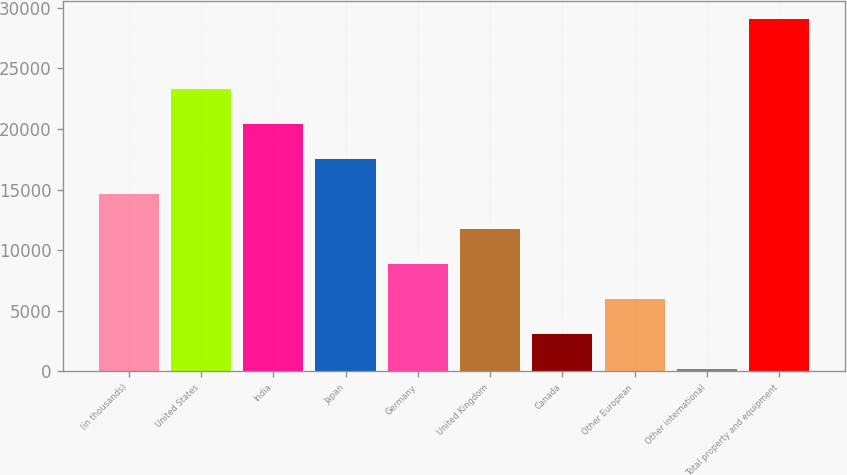<chart> <loc_0><loc_0><loc_500><loc_500><bar_chart><fcel>(in thousands)<fcel>United States<fcel>India<fcel>Japan<fcel>Germany<fcel>United Kingdom<fcel>Canada<fcel>Other European<fcel>Other international<fcel>Total property and equipment<nl><fcel>14620.5<fcel>23297.4<fcel>20405.1<fcel>17512.8<fcel>8835.9<fcel>11728.2<fcel>3051.3<fcel>5943.6<fcel>159<fcel>29082<nl></chart> 